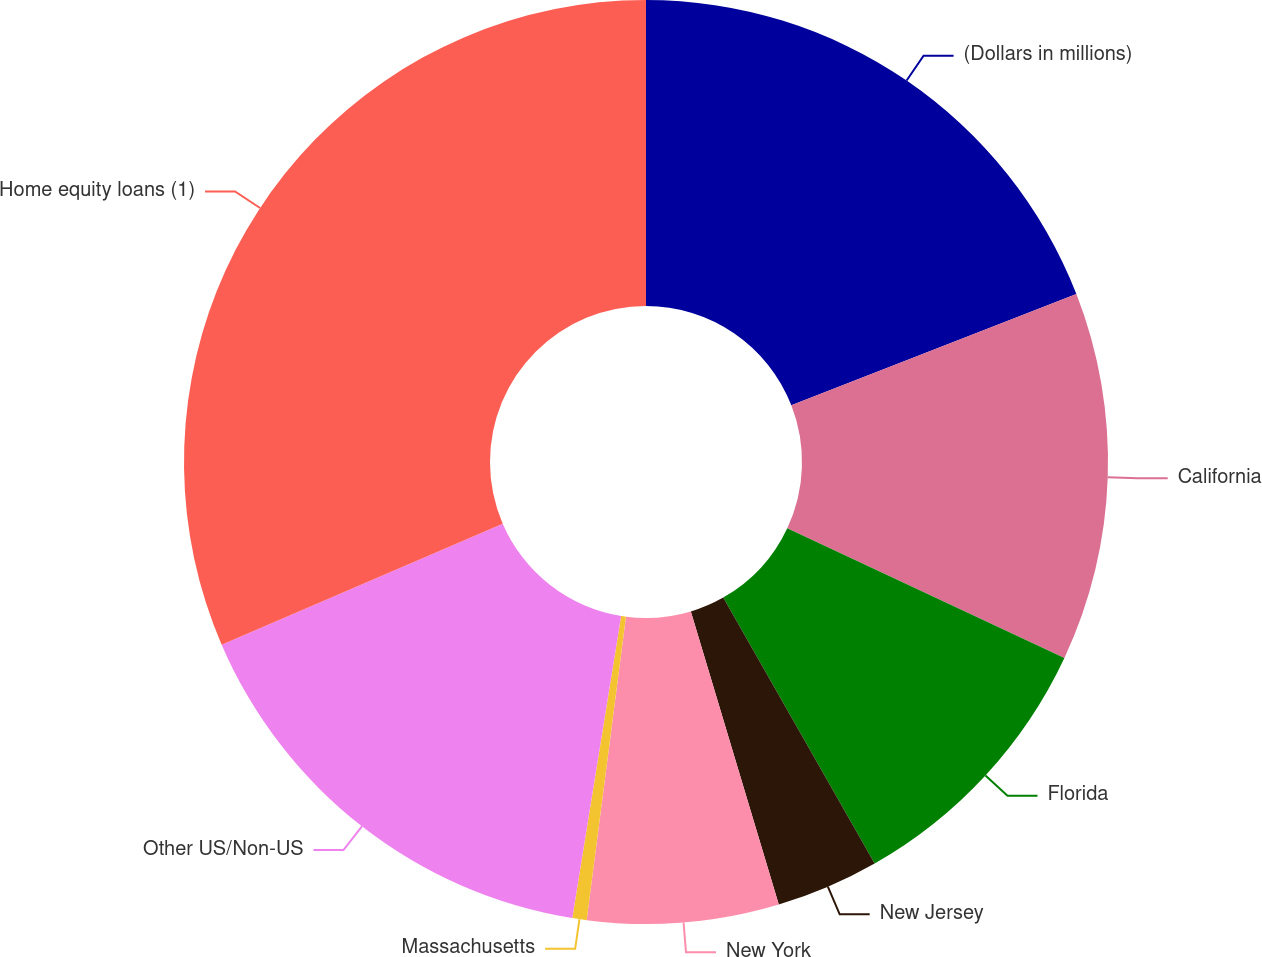Convert chart to OTSL. <chart><loc_0><loc_0><loc_500><loc_500><pie_chart><fcel>(Dollars in millions)<fcel>California<fcel>Florida<fcel>New Jersey<fcel>New York<fcel>Massachusetts<fcel>Other US/Non-US<fcel>Home equity loans (1)<nl><fcel>19.08%<fcel>12.89%<fcel>9.79%<fcel>3.6%<fcel>6.69%<fcel>0.5%<fcel>15.98%<fcel>31.47%<nl></chart> 